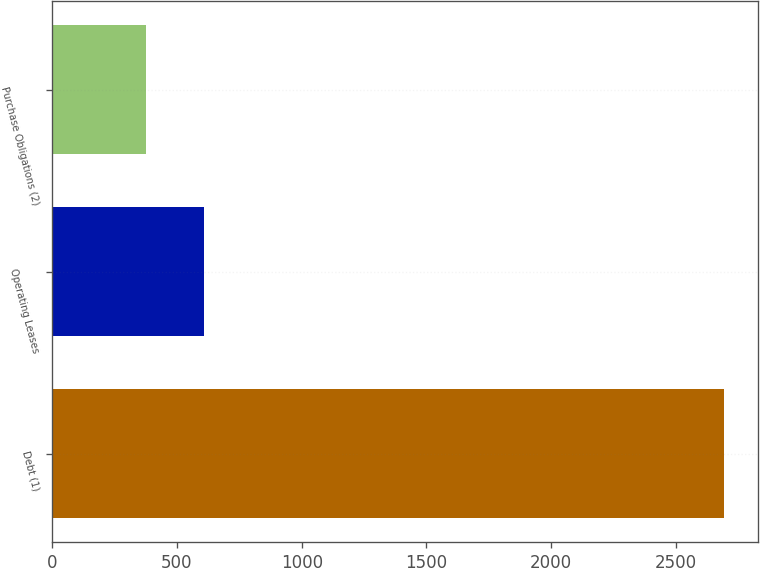Convert chart. <chart><loc_0><loc_0><loc_500><loc_500><bar_chart><fcel>Debt (1)<fcel>Operating Leases<fcel>Purchase Obligations (2)<nl><fcel>2694<fcel>607.8<fcel>376<nl></chart> 